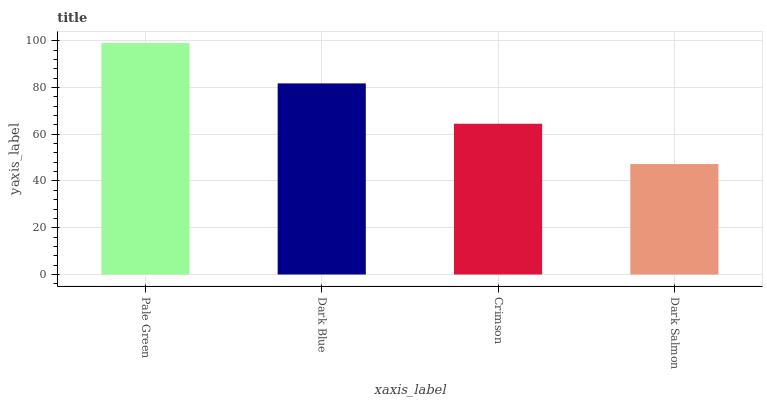Is Dark Salmon the minimum?
Answer yes or no. Yes. Is Pale Green the maximum?
Answer yes or no. Yes. Is Dark Blue the minimum?
Answer yes or no. No. Is Dark Blue the maximum?
Answer yes or no. No. Is Pale Green greater than Dark Blue?
Answer yes or no. Yes. Is Dark Blue less than Pale Green?
Answer yes or no. Yes. Is Dark Blue greater than Pale Green?
Answer yes or no. No. Is Pale Green less than Dark Blue?
Answer yes or no. No. Is Dark Blue the high median?
Answer yes or no. Yes. Is Crimson the low median?
Answer yes or no. Yes. Is Pale Green the high median?
Answer yes or no. No. Is Dark Salmon the low median?
Answer yes or no. No. 